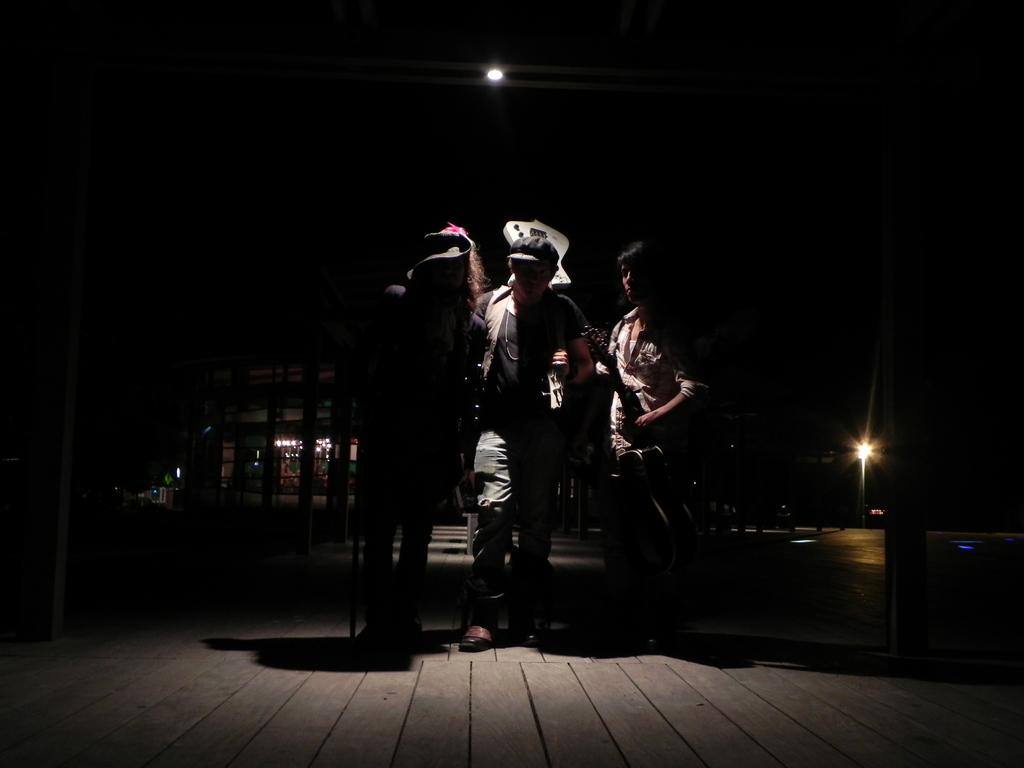What is the overall lighting condition in the image? The image is dark. How many people are present in the image? There are three persons in the image. What type of flooring can be seen in the image? The floor in the image appears to be wooden. What type of print is visible on the wool clothing of the persons in the image? There is no mention of clothing or wool in the provided facts, so it cannot be determined if any print is visible on the persons' clothing. 